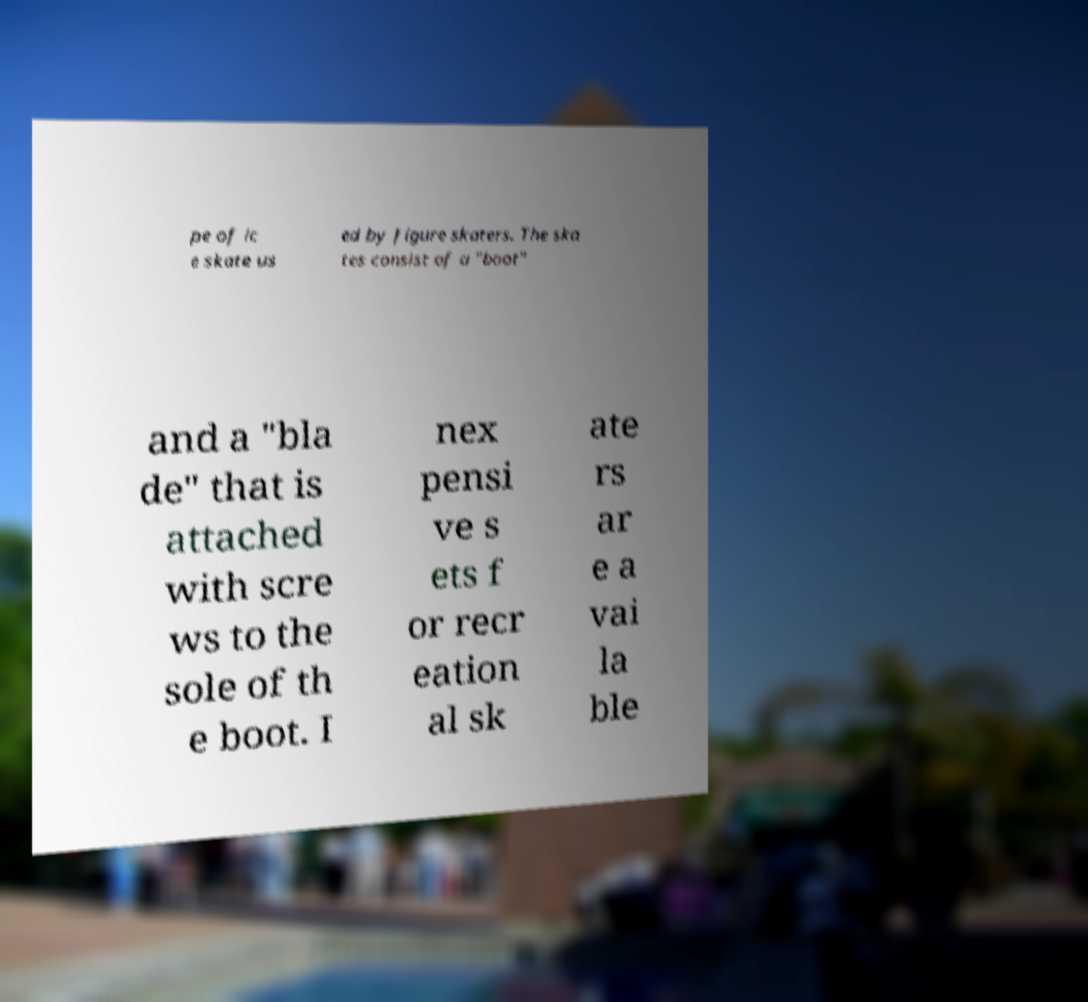Can you accurately transcribe the text from the provided image for me? pe of ic e skate us ed by figure skaters. The ska tes consist of a "boot" and a "bla de" that is attached with scre ws to the sole of th e boot. I nex pensi ve s ets f or recr eation al sk ate rs ar e a vai la ble 